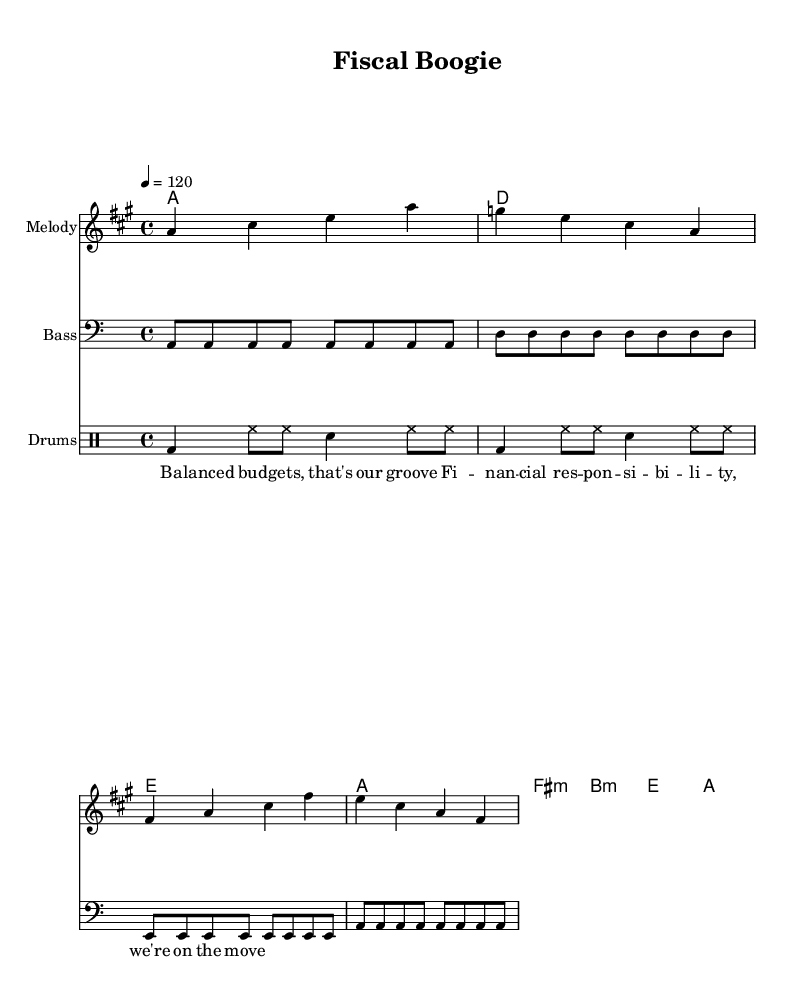What is the key signature of this music? The key signature is A major, which has three sharps: F sharp, C sharp, and G sharp. You can identify the key signature by looking at the sharp symbols at the beginning of the staff.
Answer: A major What is the time signature of this music? The time signature is 4/4, which means there are four beats in each measure and a quarter note gets one beat. This can be seen at the beginning of the staff where the time signature is displayed.
Answer: 4/4 What is the tempo marked in this piece? The tempo is marked as 4=120, indicating a speed of 120 beats per minute. This shows how fast the piece is intended to be played, and it's a common tempo marking for lively music.
Answer: 120 How many measures are present in the melody? There are eight measures in the melody. Counting the vertical lines that separate the measures in the staff gives you the total number.
Answer: 8 What type of chords are used in the harmony section? The harmony section contains both major and minor chords, identifiable by their symbols: 'A', 'D', 'E' are major chords, while 'fis:m' and 'b:m' indicate minor chords. This mix is typical in disco music to create that upbeat feel.
Answer: Major and minor What instrument is indicated for the drum patterns? The drum patterns are assigned to the 'Drums'. This is typically indicated at the start of the drum staff section in the sheet music, where the instrument name is labeled.
Answer: Drums What is the lyrical theme of this disco track? The lyrical theme focuses on 'Balanced budgets' and 'Financial responsibility', which indicates a support for economic growth and fiscal responsibility in a playful manner suited for disco music.
Answer: Economic growth and financial responsibility 